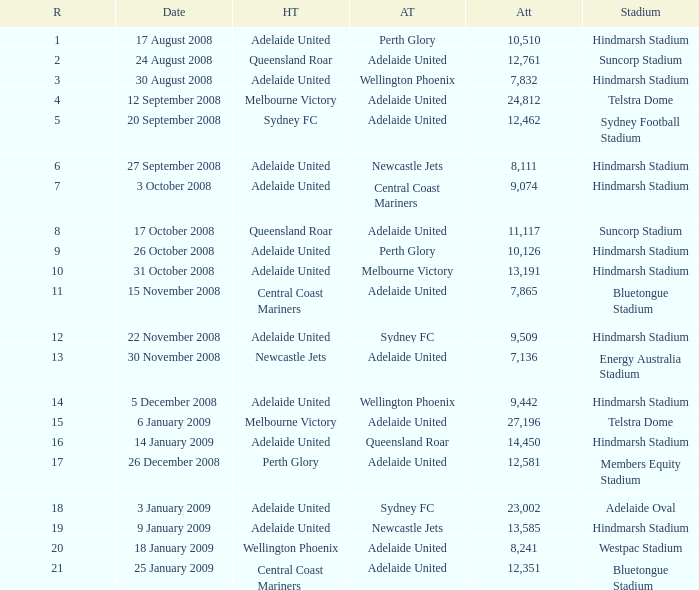What is the least round for the game played at Members Equity Stadium in from of 12,581 people? None. 